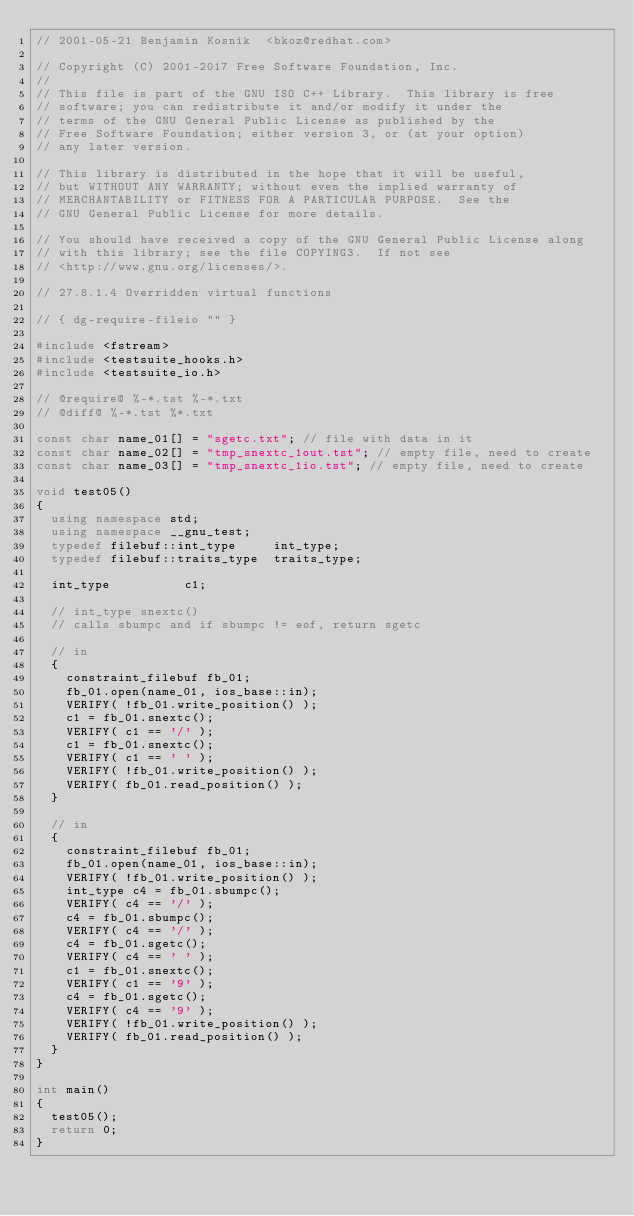Convert code to text. <code><loc_0><loc_0><loc_500><loc_500><_C++_>// 2001-05-21 Benjamin Kosnik  <bkoz@redhat.com>

// Copyright (C) 2001-2017 Free Software Foundation, Inc.
//
// This file is part of the GNU ISO C++ Library.  This library is free
// software; you can redistribute it and/or modify it under the
// terms of the GNU General Public License as published by the
// Free Software Foundation; either version 3, or (at your option)
// any later version.

// This library is distributed in the hope that it will be useful,
// but WITHOUT ANY WARRANTY; without even the implied warranty of
// MERCHANTABILITY or FITNESS FOR A PARTICULAR PURPOSE.  See the
// GNU General Public License for more details.

// You should have received a copy of the GNU General Public License along
// with this library; see the file COPYING3.  If not see
// <http://www.gnu.org/licenses/>.

// 27.8.1.4 Overridden virtual functions

// { dg-require-fileio "" }

#include <fstream>
#include <testsuite_hooks.h>
#include <testsuite_io.h>

// @require@ %-*.tst %-*.txt
// @diff@ %-*.tst %*.txt

const char name_01[] = "sgetc.txt"; // file with data in it
const char name_02[] = "tmp_snextc_1out.tst"; // empty file, need to create
const char name_03[] = "tmp_snextc_1io.tst"; // empty file, need to create

void test05() 
{
  using namespace std;
  using namespace __gnu_test;
  typedef filebuf::int_type 	int_type;
  typedef filebuf::traits_type 	traits_type;

  int_type 			c1;

  // int_type snextc()
  // calls sbumpc and if sbumpc != eof, return sgetc
  
  // in
  {
    constraint_filebuf fb_01; 
    fb_01.open(name_01, ios_base::in);
    VERIFY( !fb_01.write_position() );
    c1 = fb_01.snextc();
    VERIFY( c1 == '/' );
    c1 = fb_01.snextc();
    VERIFY( c1 == ' ' );
    VERIFY( !fb_01.write_position() );
    VERIFY( fb_01.read_position() );
  }

  // in
  {  
    constraint_filebuf fb_01; 
    fb_01.open(name_01, ios_base::in);
    VERIFY( !fb_01.write_position() );
    int_type c4 = fb_01.sbumpc();
    VERIFY( c4 == '/' );
    c4 = fb_01.sbumpc();
    VERIFY( c4 == '/' );
    c4 = fb_01.sgetc();
    VERIFY( c4 == ' ' );
    c1 = fb_01.snextc();
    VERIFY( c1 == '9' );
    c4 = fb_01.sgetc();
    VERIFY( c4 == '9' );
    VERIFY( !fb_01.write_position() );
    VERIFY( fb_01.read_position() );
  }
}

int main() 
{
  test05();
  return 0;
}
</code> 